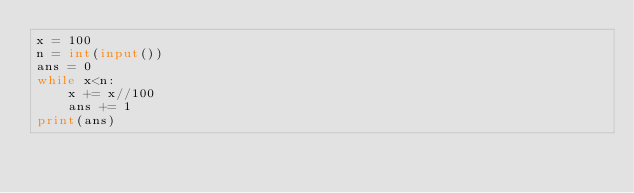<code> <loc_0><loc_0><loc_500><loc_500><_Python_>x = 100
n = int(input())
ans = 0
while x<n:
    x += x//100
    ans += 1
print(ans)</code> 